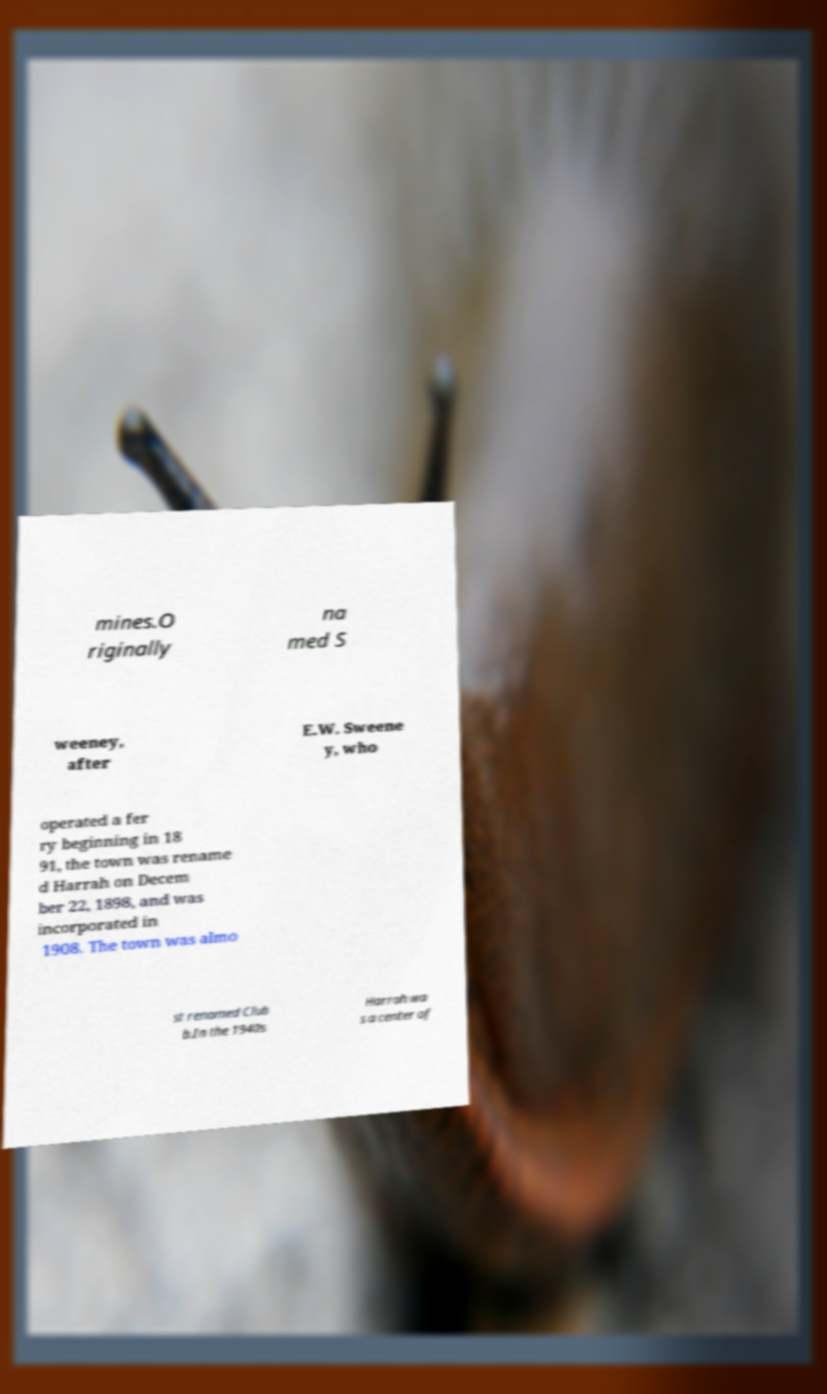Can you read and provide the text displayed in the image?This photo seems to have some interesting text. Can you extract and type it out for me? mines.O riginally na med S weeney, after E.W. Sweene y, who operated a fer ry beginning in 18 91, the town was rename d Harrah on Decem ber 22, 1898, and was incorporated in 1908. The town was almo st renamed Club b.In the 1940s Harrah wa s a center of 